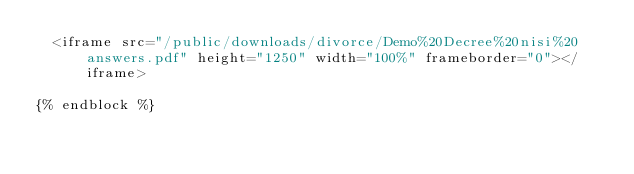Convert code to text. <code><loc_0><loc_0><loc_500><loc_500><_HTML_>  <iframe src="/public/downloads/divorce/Demo%20Decree%20nisi%20answers.pdf" height="1250" width="100%" frameborder="0"></iframe>

{% endblock %}</code> 